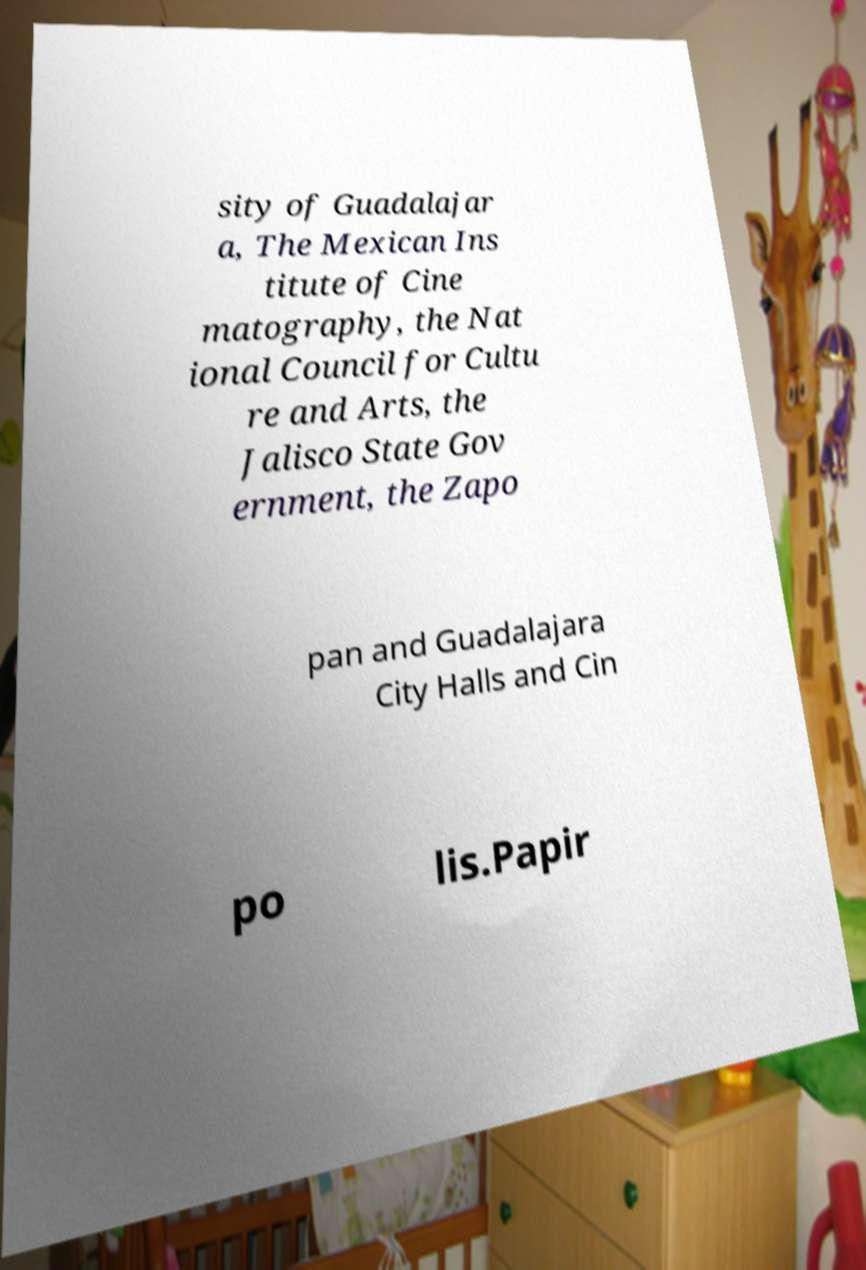Please identify and transcribe the text found in this image. sity of Guadalajar a, The Mexican Ins titute of Cine matography, the Nat ional Council for Cultu re and Arts, the Jalisco State Gov ernment, the Zapo pan and Guadalajara City Halls and Cin po lis.Papir 